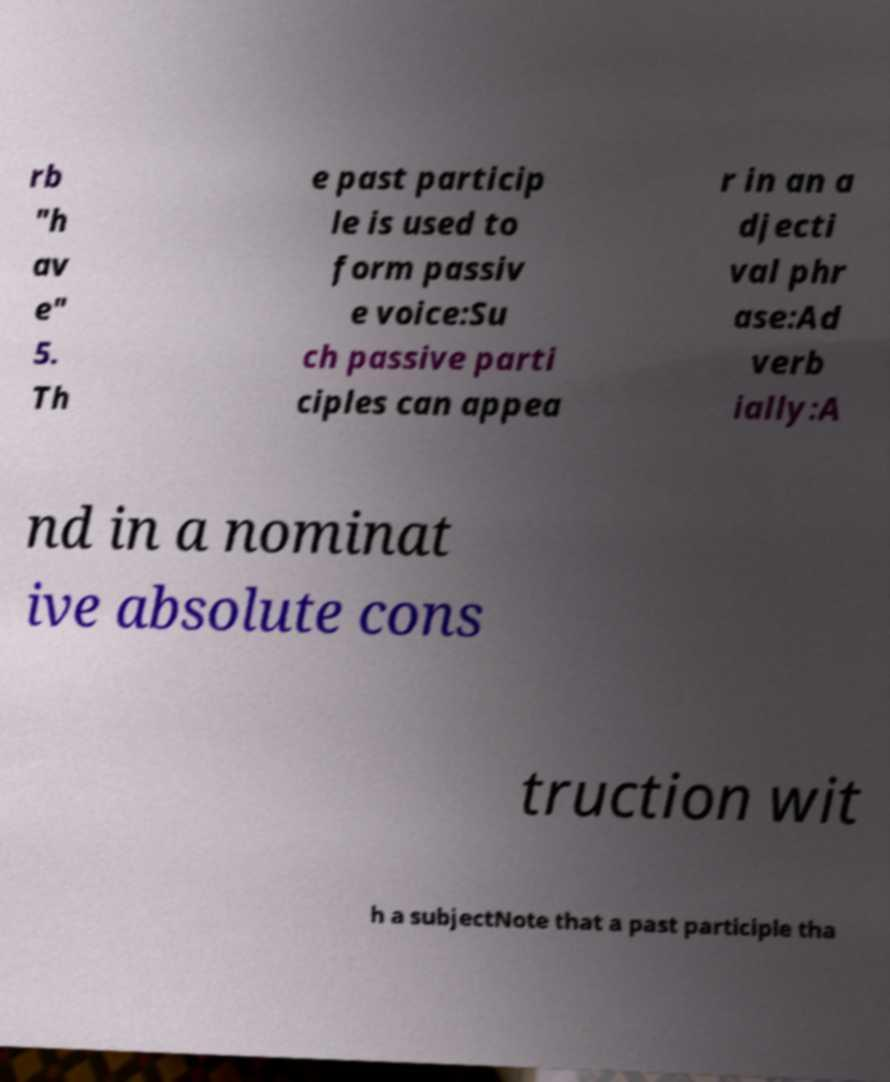Can you read and provide the text displayed in the image?This photo seems to have some interesting text. Can you extract and type it out for me? rb "h av e" 5. Th e past particip le is used to form passiv e voice:Su ch passive parti ciples can appea r in an a djecti val phr ase:Ad verb ially:A nd in a nominat ive absolute cons truction wit h a subjectNote that a past participle tha 